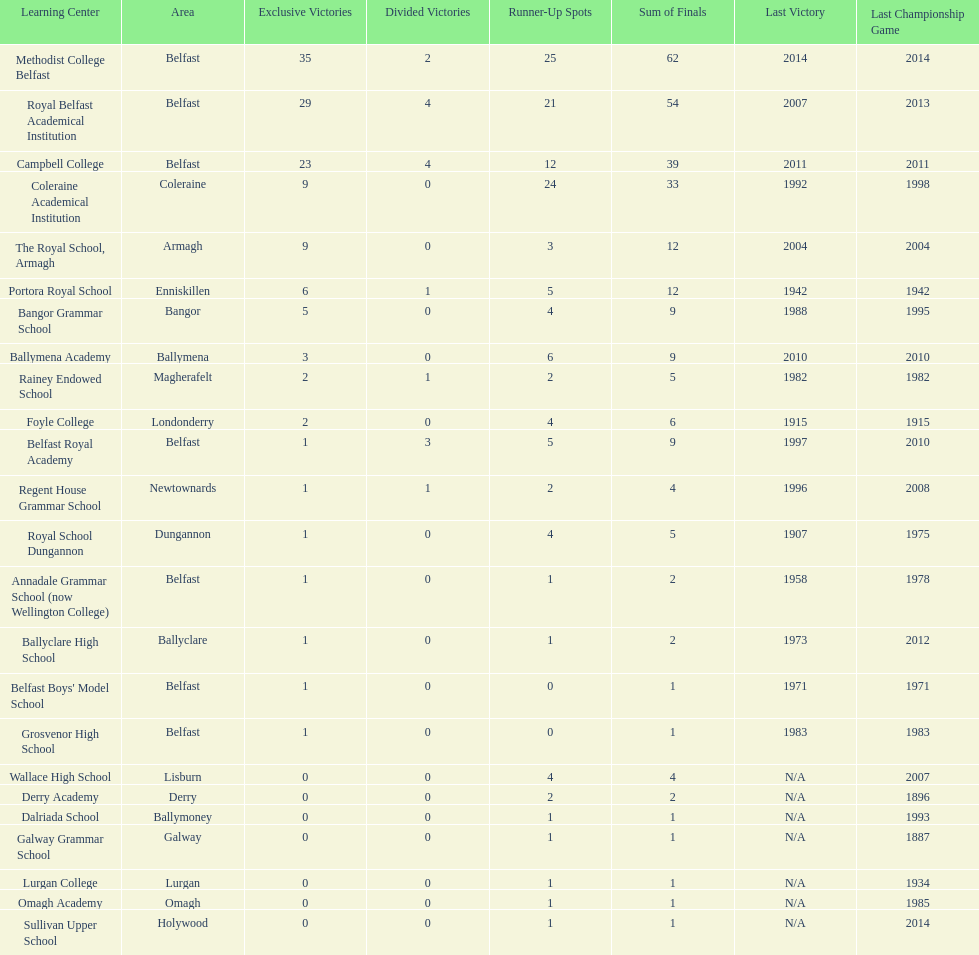How many schools had above 5 outright titles? 6. 